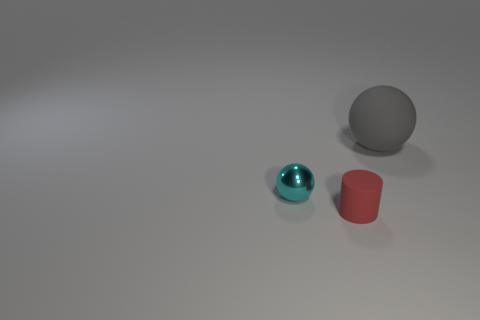There is a cylinder that is the same size as the cyan object; what is it made of?
Keep it short and to the point. Rubber. There is another big gray object that is the same shape as the metallic object; what is its material?
Offer a very short reply. Rubber. What number of other things are the same size as the red rubber cylinder?
Give a very brief answer. 1. What number of small balls are the same color as the large sphere?
Your answer should be compact. 0. The gray rubber thing has what shape?
Offer a very short reply. Sphere. What color is the thing that is behind the matte cylinder and to the left of the gray object?
Your answer should be very brief. Cyan. What is the material of the red cylinder?
Provide a short and direct response. Rubber. What shape is the matte object that is in front of the gray sphere?
Provide a succinct answer. Cylinder. What is the color of the cylinder that is the same size as the metallic object?
Ensure brevity in your answer.  Red. Do the ball in front of the gray rubber thing and the gray thing have the same material?
Your answer should be very brief. No. 